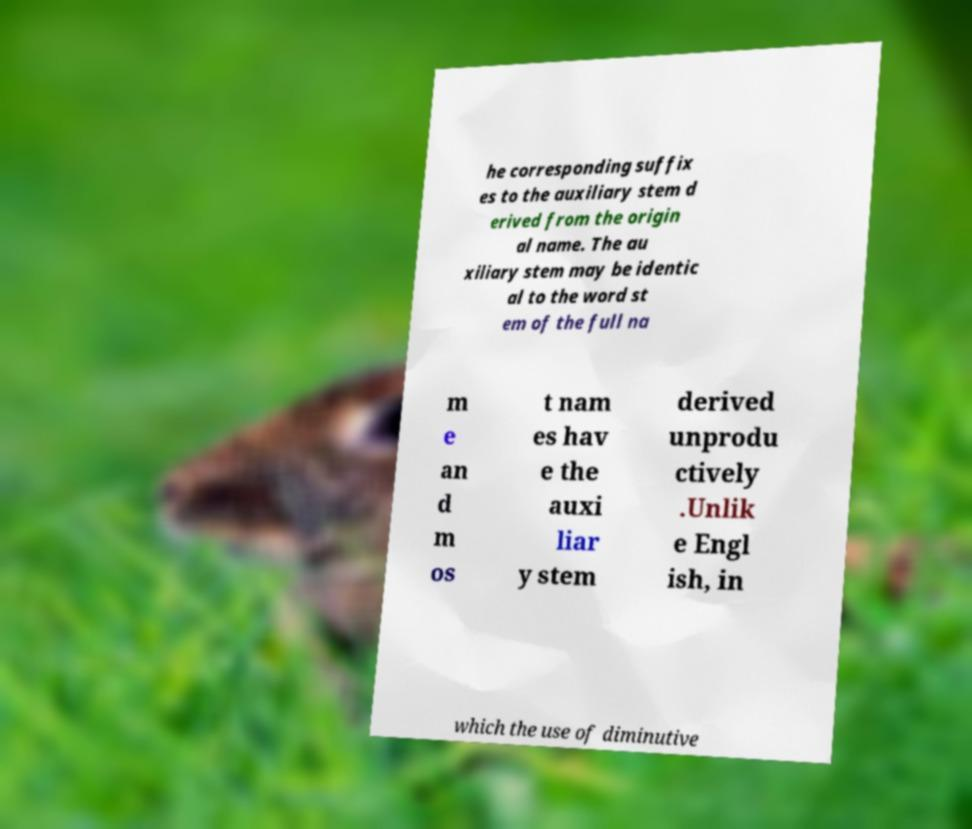Could you extract and type out the text from this image? he corresponding suffix es to the auxiliary stem d erived from the origin al name. The au xiliary stem may be identic al to the word st em of the full na m e an d m os t nam es hav e the auxi liar y stem derived unprodu ctively .Unlik e Engl ish, in which the use of diminutive 